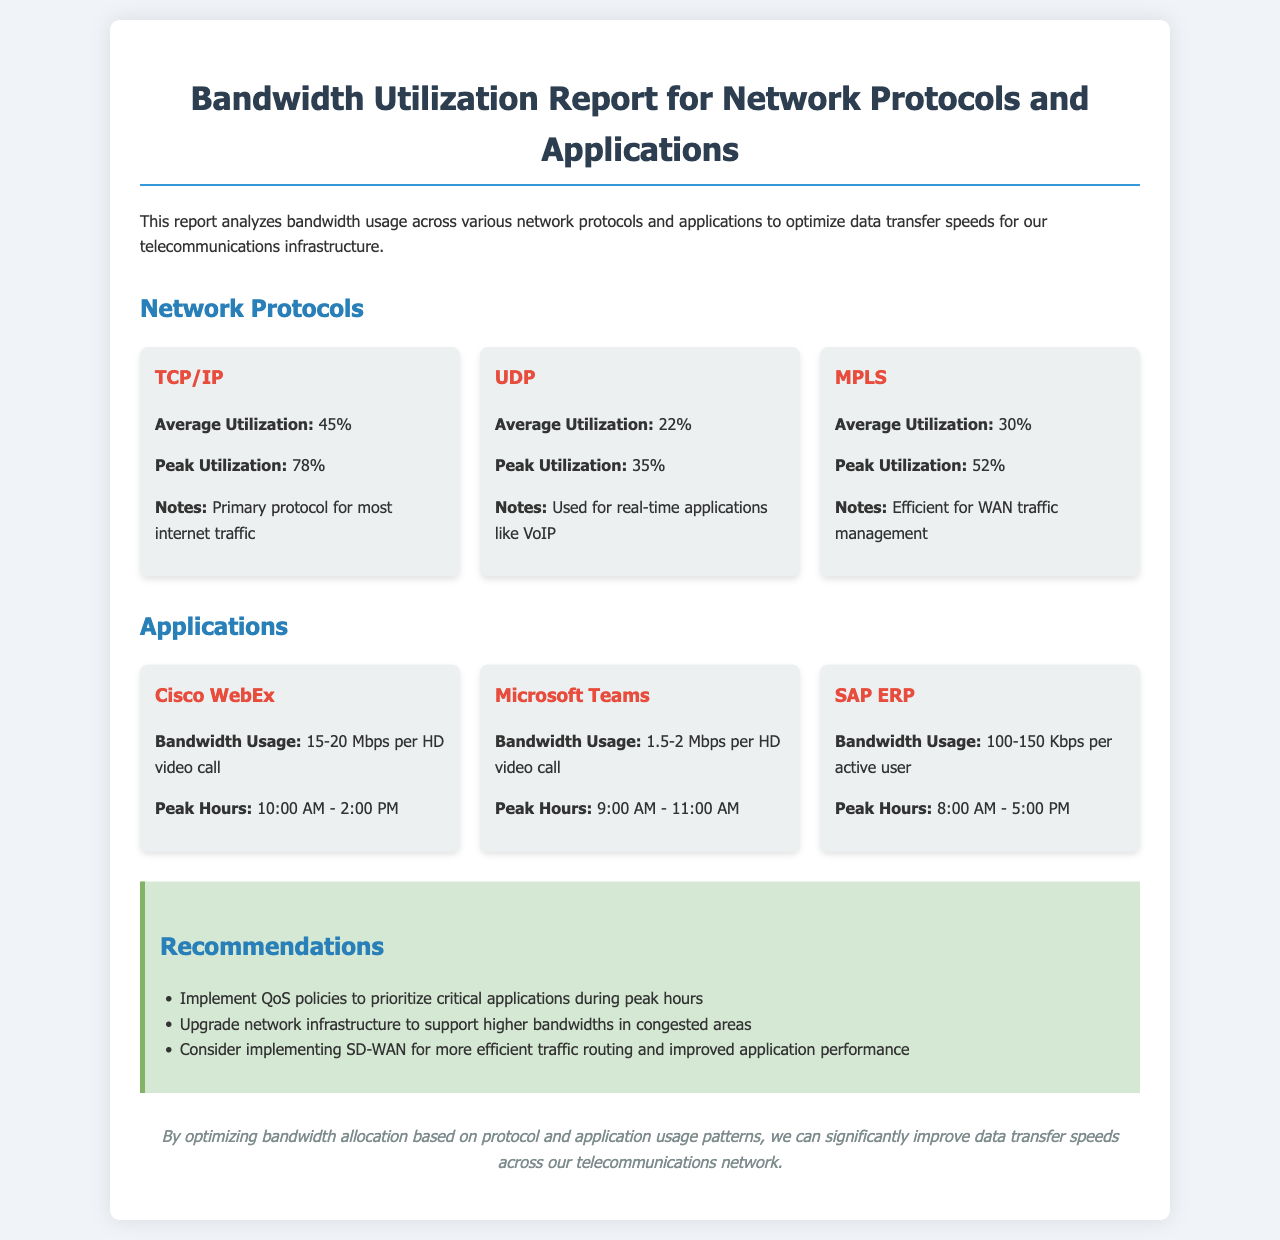What is the average utilization of TCP/IP? The average utilization is specifically stated in the document as 45%.
Answer: 45% What bandwidth usage does Cisco WebEx require per HD video call? The bandwidth usage is mentioned in the document as 15-20 Mbps per HD video call.
Answer: 15-20 Mbps What is the peak utilization percentage for UDP? The peak utilization for UDP is listed as 35%.
Answer: 35% What recommendation is made about network infrastructure? The document suggests upgrading network infrastructure to support higher bandwidths in congested areas.
Answer: Upgrade network infrastructure What are the peak hours for Microsoft Teams? The document specifies the peak hours for Microsoft Teams as 9:00 AM - 11:00 AM.
Answer: 9:00 AM - 11:00 AM Which protocol has the highest average utilization? The average utilization percentages are noted, and TCP/IP has the highest average at 45%.
Answer: TCP/IP What is the average utilization of MPLS? The average utilization for MPLS is recorded as 30%.
Answer: 30% What is the bandwidth usage for SAP ERP per active user? The document outlines the bandwidth usage for SAP ERP as 100-150 Kbps per active user.
Answer: 100-150 Kbps What application uses UDP for real-time communication? The document indicates that UDP is used for real-time applications like VoIP.
Answer: VoIP 